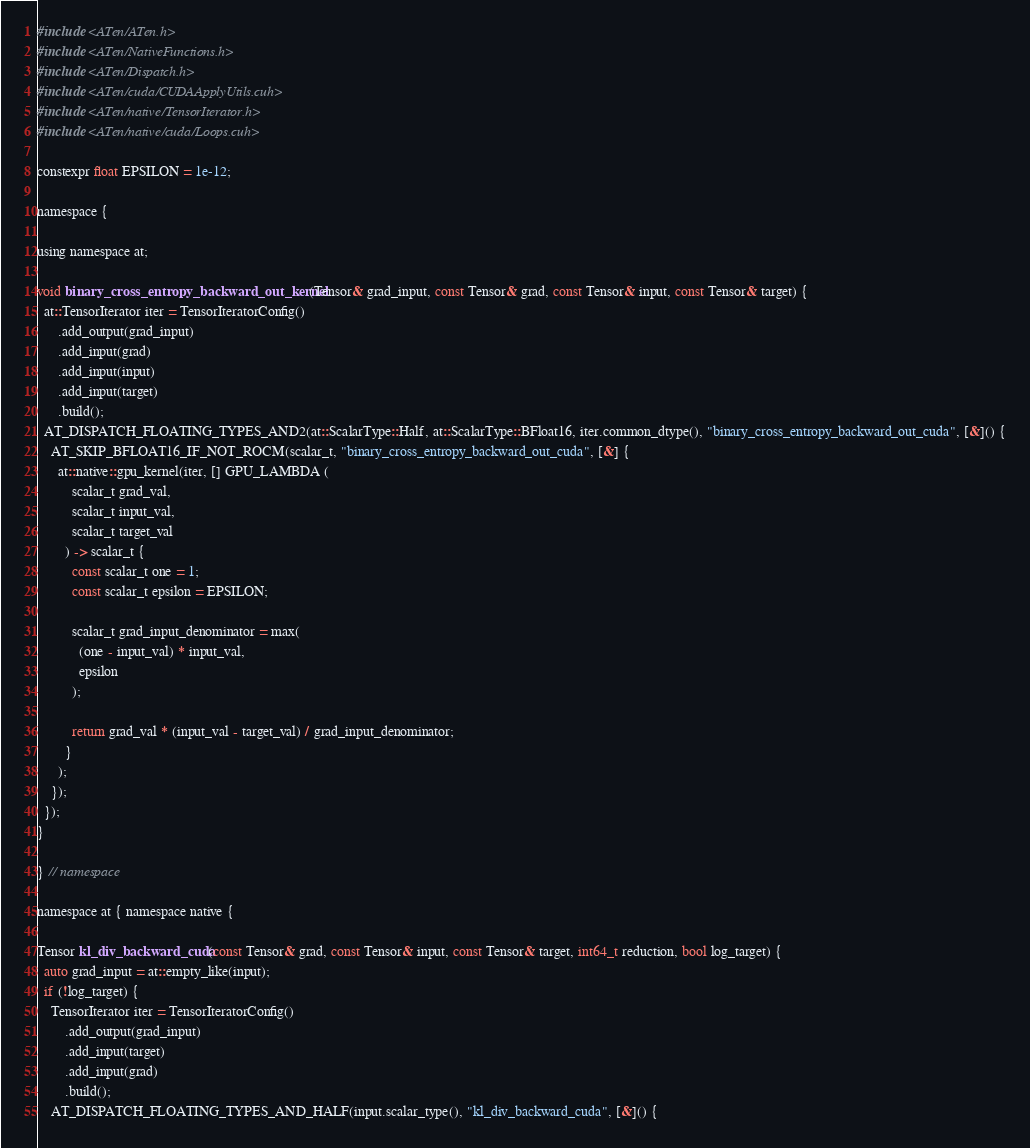<code> <loc_0><loc_0><loc_500><loc_500><_Cuda_>#include <ATen/ATen.h>
#include <ATen/NativeFunctions.h>
#include <ATen/Dispatch.h>
#include <ATen/cuda/CUDAApplyUtils.cuh>
#include <ATen/native/TensorIterator.h>
#include <ATen/native/cuda/Loops.cuh>

constexpr float EPSILON = 1e-12;

namespace {

using namespace at;

void binary_cross_entropy_backward_out_kernel(Tensor& grad_input, const Tensor& grad, const Tensor& input, const Tensor& target) {
  at::TensorIterator iter = TensorIteratorConfig()
      .add_output(grad_input)
      .add_input(grad)
      .add_input(input)
      .add_input(target)
      .build();
  AT_DISPATCH_FLOATING_TYPES_AND2(at::ScalarType::Half, at::ScalarType::BFloat16, iter.common_dtype(), "binary_cross_entropy_backward_out_cuda", [&]() {
    AT_SKIP_BFLOAT16_IF_NOT_ROCM(scalar_t, "binary_cross_entropy_backward_out_cuda", [&] {
      at::native::gpu_kernel(iter, [] GPU_LAMBDA (
          scalar_t grad_val,
          scalar_t input_val,
          scalar_t target_val
        ) -> scalar_t {
          const scalar_t one = 1;
          const scalar_t epsilon = EPSILON;

          scalar_t grad_input_denominator = max(
            (one - input_val) * input_val,
            epsilon
          );

          return grad_val * (input_val - target_val) / grad_input_denominator;
        }
      );
    });
  });
}

} // namespace

namespace at { namespace native {

Tensor kl_div_backward_cuda(const Tensor& grad, const Tensor& input, const Tensor& target, int64_t reduction, bool log_target) {
  auto grad_input = at::empty_like(input);
  if (!log_target) {
    TensorIterator iter = TensorIteratorConfig()
        .add_output(grad_input)
        .add_input(target)
        .add_input(grad)
        .build();
    AT_DISPATCH_FLOATING_TYPES_AND_HALF(input.scalar_type(), "kl_div_backward_cuda", [&]() {</code> 